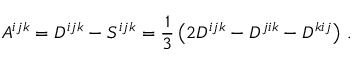<formula> <loc_0><loc_0><loc_500><loc_500>A ^ { i j k } = D ^ { i j k } - S ^ { i j k } = \frac { 1 } { 3 } \left ( 2 D ^ { i j k } - D ^ { j i k } - D ^ { k i j } \right ) \, .</formula> 